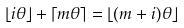<formula> <loc_0><loc_0><loc_500><loc_500>\lfloor i \theta \rfloor + \lceil m \theta \rceil = \lfloor ( m + i ) \theta \rfloor</formula> 